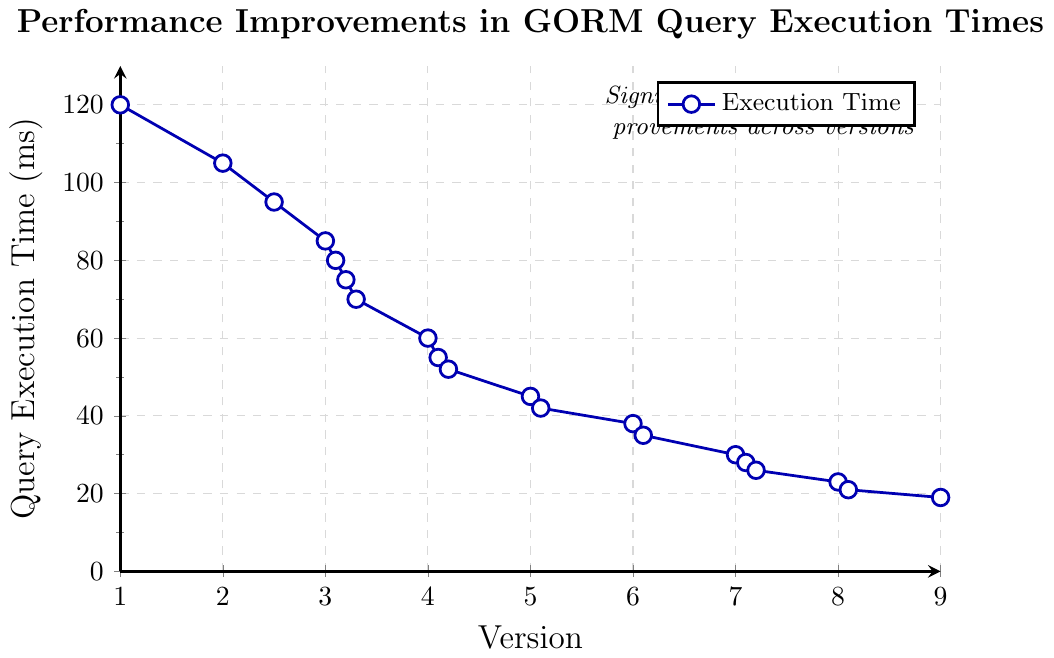What's the average query execution time for versions 1.0, 4.0, and 9.0? To find the average query execution time, we sum the execution times for versions 1.0, 4.0, and 9.0: 120 ms + 60 ms + 19 ms = 199 ms. We then divide this sum by the number of versions, which is 3: 199 ms / 3 = 66.33 ms
Answer: 66.33 ms Which version shows the largest drop in query execution time compared to the previous version? We need to calculate the differences in query execution times between consecutive versions. The largest drop is from version 3.3 to version 4.0, where the execution time drops from 70 ms to 60 ms, a decrease of 10 ms
Answer: Version 4.0 How does the query execution time change from version 7.2 to version 9.0? The query execution time for version 7.2 is 26 ms, and for version 9.0, it is 19 ms. The change is 26 ms - 19 ms = 7 ms, so the execution time decreases by 7 ms
Answer: Decreases by 7 ms By what percentage does the query execution time decrease from version 1.0 to version 9.0? The initial query execution time is 120 ms and the final is 19 ms. The decrease is 120 ms - 19 ms = 101 ms. To find the percentage decrease, divide the decrease by the initial time and multiply by 100: (101 ms / 120 ms) * 100 ≈ 84.17%
Answer: 84.17% What is the trend of the query execution times from version 5.0 to version 6.0? From the data, the query execution time decreases consistently from version 5.0 (45 ms) to version 6.0 (38 ms) and continues to decrease to version 6.1 (35 ms)
Answer: Decreasing trend Compare the query execution times between versions 2.5 and 7.0. Which one is higher? The query execution time for version 2.5 is 95 ms, while for version 7.0 it is 30 ms. Therefore, version 2.5 has a higher execution time than version 7.0
Answer: Version 2.5 is higher What is the total reduction in query execution times from version 4.0 to version 5.0? The query execution time for version 4.0 is 60 ms, and for version 5.0 it is 45 ms. The total reduction is 60 ms - 45 ms = 15 ms
Answer: 15 ms What is the visual indicator used to mark data points in the chart? The visual indicator for data points in the chart is a blue line with white-filled circular markers
Answer: Blue line with white-filled circles 